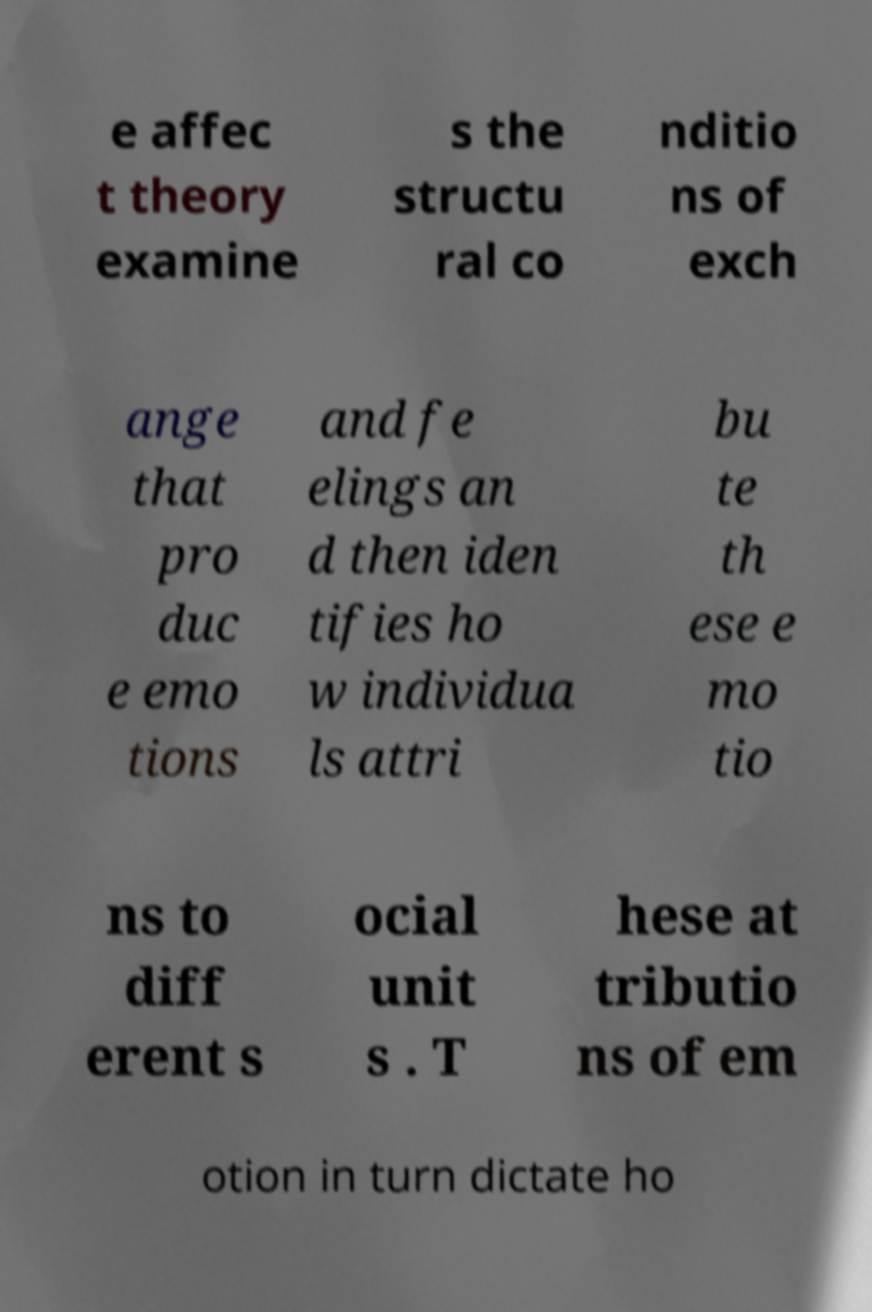Could you assist in decoding the text presented in this image and type it out clearly? e affec t theory examine s the structu ral co nditio ns of exch ange that pro duc e emo tions and fe elings an d then iden tifies ho w individua ls attri bu te th ese e mo tio ns to diff erent s ocial unit s . T hese at tributio ns of em otion in turn dictate ho 